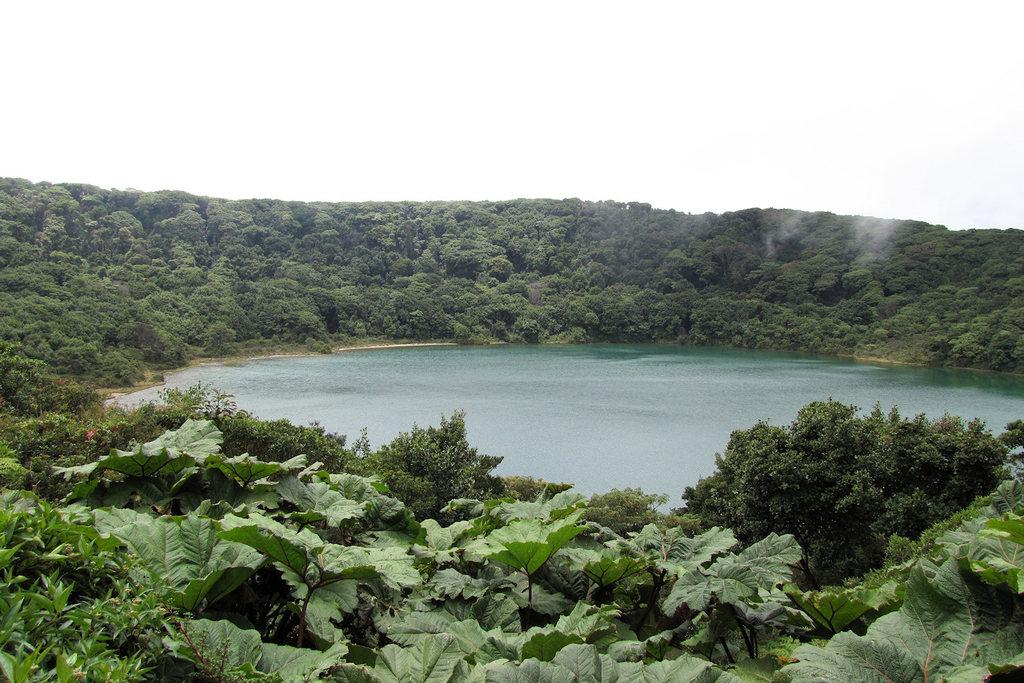Where was the image taken? The image is taken outdoors. What is the main feature in the middle of the image? There is a pond with water in the middle of the image. What type of vegetation can be seen in the image? There are many trees and plants with green leaves, stems, and branches in the image. Can you see any planes flying in the sky in the image? There are no planes visible in the image. Are there any worms crawling on the plants in the image? There is no indication of worms or any other animals on the plants in the image. 